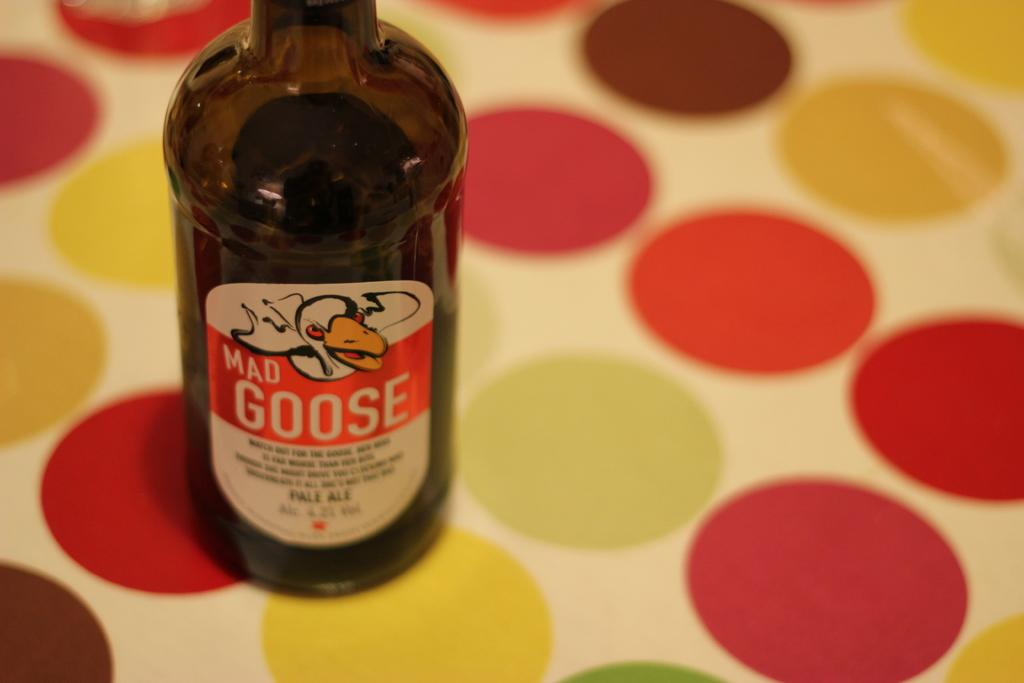<image>
Write a terse but informative summary of the picture. Mad Goose drink that is sitting on a table with a bunch of colored circles. 